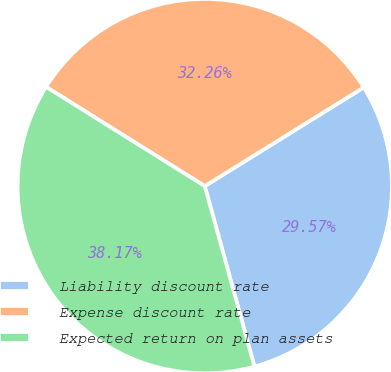<chart> <loc_0><loc_0><loc_500><loc_500><pie_chart><fcel>Liability discount rate<fcel>Expense discount rate<fcel>Expected return on plan assets<nl><fcel>29.57%<fcel>32.26%<fcel>38.17%<nl></chart> 